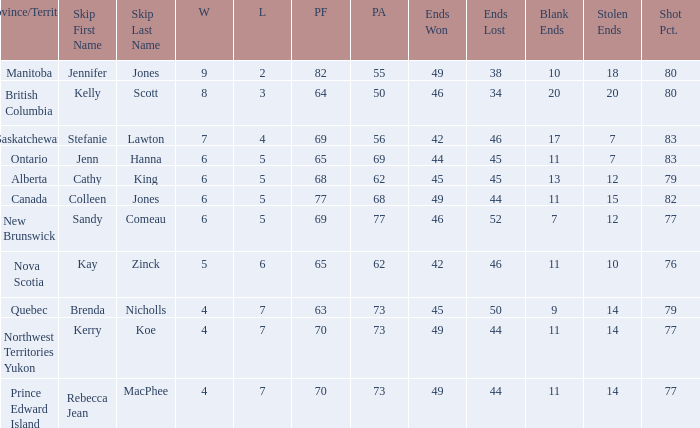What is the minimum PA when ends lost is 45? 62.0. 